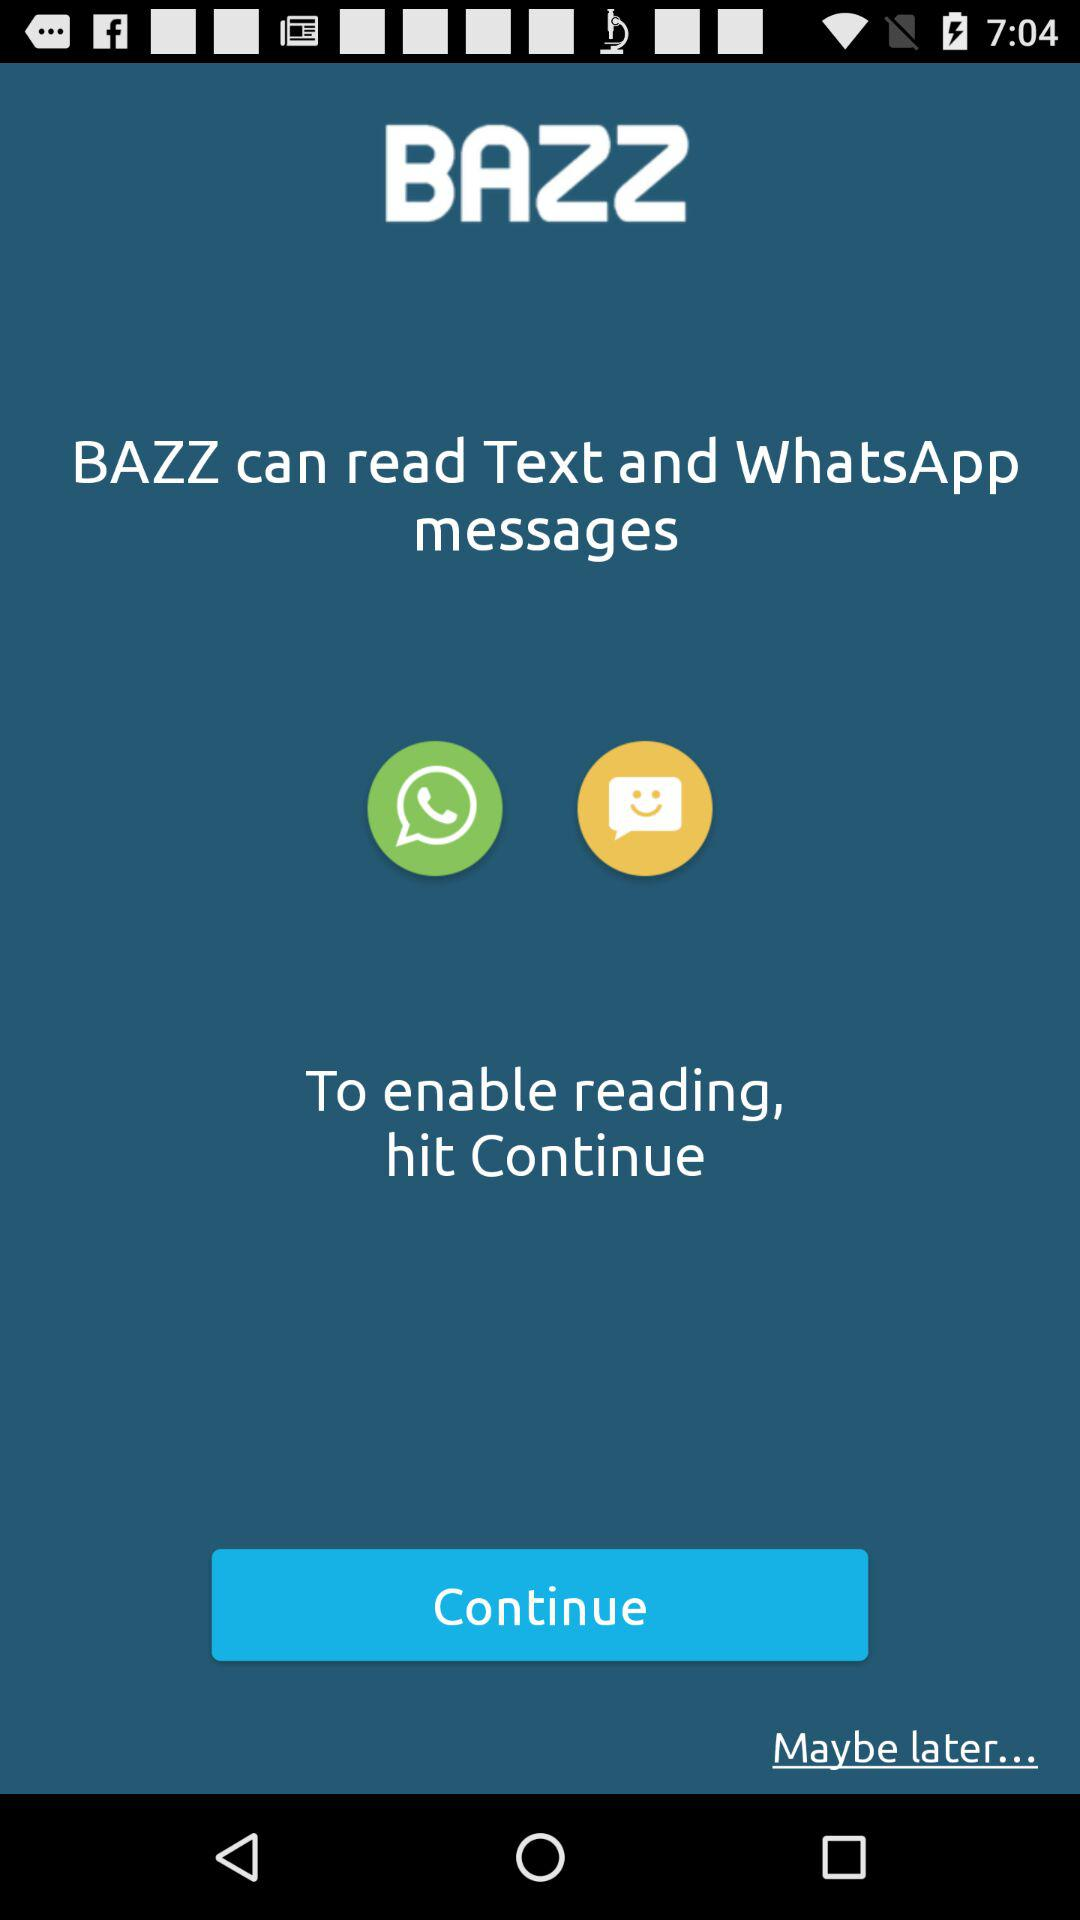What is the application name? The application name is "BAZZ". 